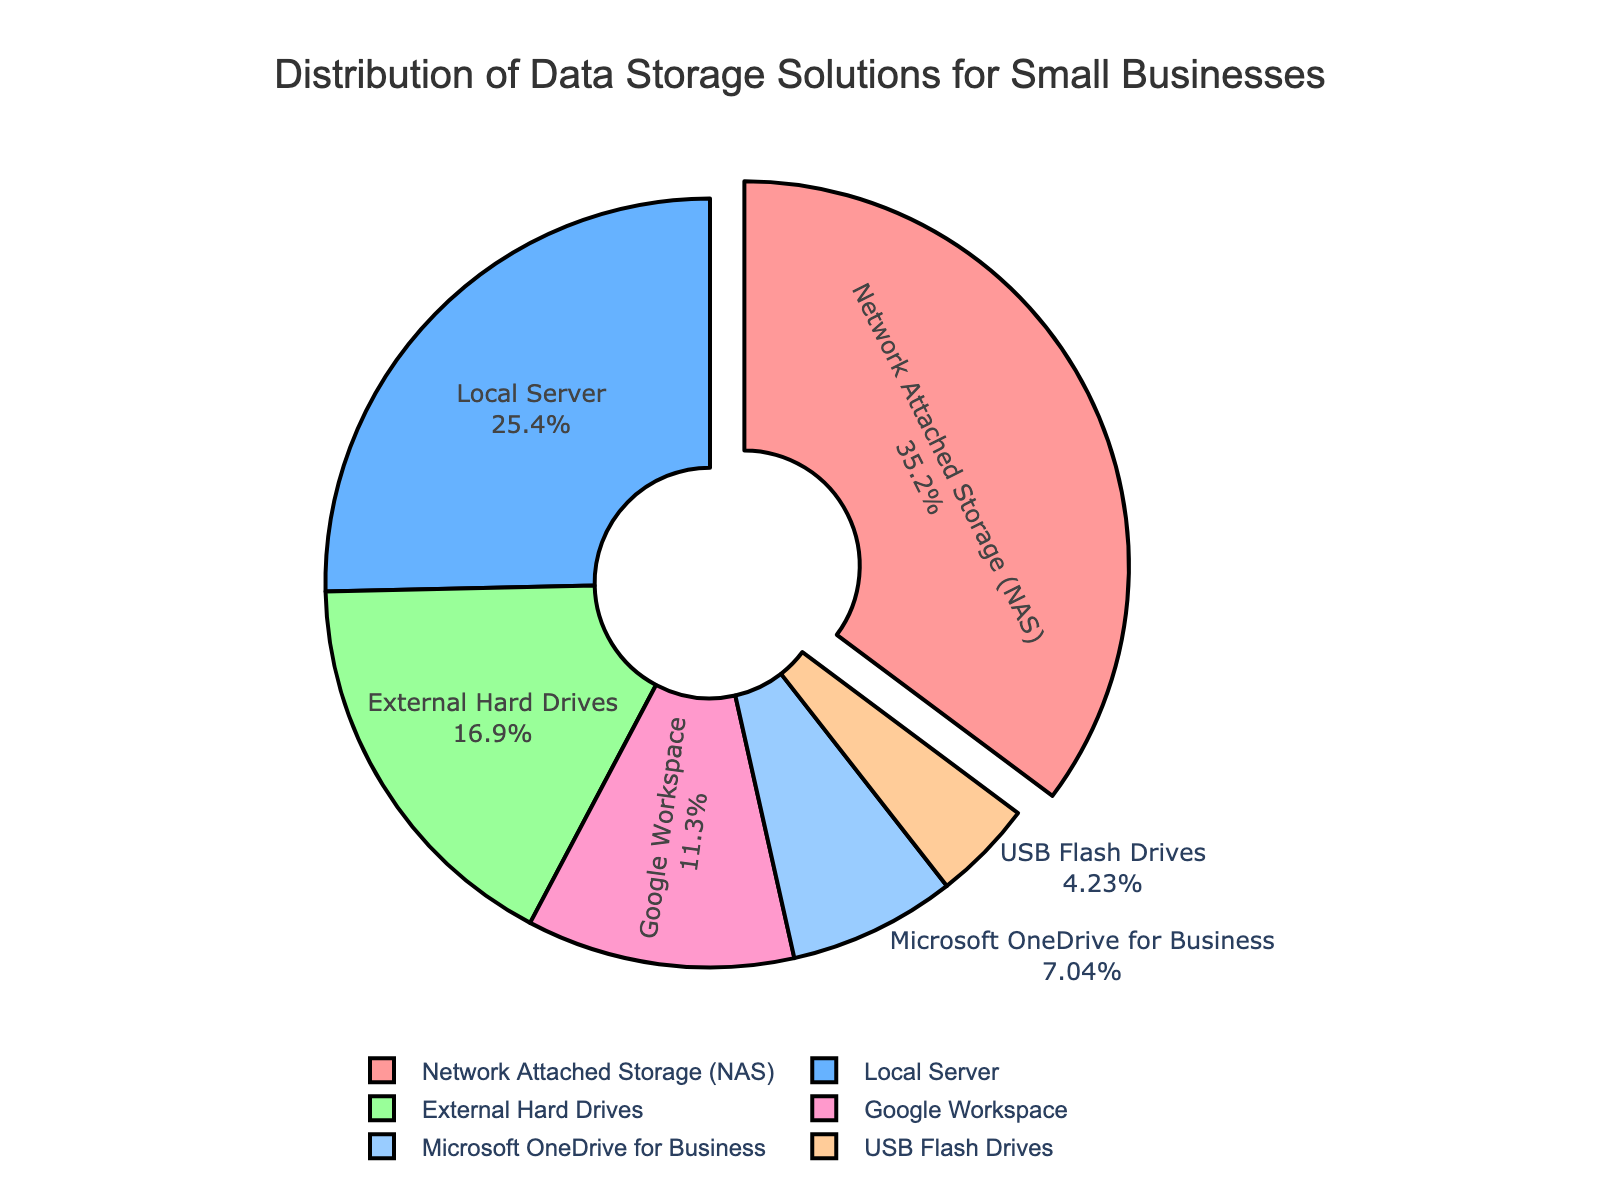What is the most popular data storage solution among small businesses? The most popular data storage solution is the one with the largest percentage. In this pie chart, it is the Network Attached Storage (NAS) with 25%.
Answer: Network Attached Storage (NAS) How much more popular is Network Attached Storage (NAS) compared to Local Server? The popularity difference can be found by subtracting the percentage of Local Server from Network Attached Storage (NAS). That is 25% - 18%.
Answer: 7% Which storage solution is the least used by small businesses? The least used storage solution is the one with the smallest percentage. USB Flash Drives have the smallest percentage, which is 3%.
Answer: USB Flash Drives What is the combined percentage of External Hard Drives and Google Workspace? To find the combined percentage, add the percentages of External Hard Drives and Google Workspace. 12% + 8% = 20%.
Answer: 20% Is the percentage of Network Attached Storage (NAS) greater than the total percentage of Microsoft OneDrive for Business and Google Workspace combined? First, find the combined percentage of Microsoft OneDrive for Business and Google Workspace, which is 5% + 8% = 13%. Then, compare it to the percentage of Network Attached Storage (NAS), which is 25%.
Answer: Yes Which segment is pulled out from the pie chart and why? The segment for Network Attached Storage (NAS) is pulled out because it has the highest percentage among all the storage solutions.
Answer: Network Attached Storage (NAS) How does the percentage of Local Server compare to the combined percentage of External Hard Drives and USB Flash Drives? First, find the combined percentage of External Hard Drives and USB Flash Drives, which is 12% + 3% = 15%. Then compare it with the percentage of Local Server, which is 18%.
Answer: Local Server is greater What percentage of data storage solutions used is cloud-based (Google Workspace and Microsoft OneDrive for Business)? Add the percentages of Google Workspace and Microsoft OneDrive for Business. 8% + 5% = 13%.
Answer: 13% Which data storage solutions collectively form half of the total distribution? Find the data storage solutions that add up to 50%. Network Attached Storage (25%) and Local Server (18%) combined make 43%, and adding External Hard Drives (12%) would surpass the half mark to 55%. So Network Attached Storage, Local Server, and External Hard Drives combined form half.
Answer: Network Attached Storage, Local Server, and External Hard Drives What is the total percentage of traditional (non-cloud) storage solutions? Add the percentages of Network Attached Storage (NAS), Local Server, External Hard Drives, and USB Flash Drives. 25% + 18% + 12% + 3% = 58%.
Answer: 58% 